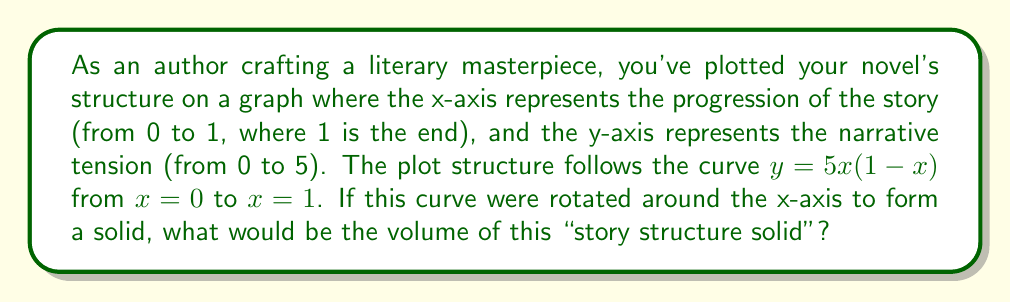Help me with this question. To solve this problem, we'll use the shell method for calculating the volume of a solid of revolution. The shell method is appropriate here because we're rotating around the x-axis, and our function is given in terms of y.

The formula for the volume using the shell method is:

$$V = 2\pi \int_a^b xf(x)dx$$

Where $f(x)$ is our function, and $a$ and $b$ are the limits of integration.

In our case:
$f(x) = 5x(1-x)$
$a = 0$
$b = 1$

Let's substitute these into our formula:

$$V = 2\pi \int_0^1 x[5x(1-x)]dx$$

Simplify the integrand:
$$V = 2\pi \int_0^1 (5x^2 - 5x^3)dx$$

Now, let's integrate:

$$V = 2\pi [\frac{5x^3}{3} - \frac{5x^4}{4}]_0^1$$

Evaluate the integral at the limits:

$$V = 2\pi [(\frac{5}{3} - \frac{5}{4}) - (0 - 0)]$$

$$V = 2\pi [\frac{20}{12} - \frac{15}{12}]$$

$$V = 2\pi [\frac{5}{12}]$$

$$V = \frac{5\pi}{6}$$

Therefore, the volume of the "story structure solid" is $\frac{5\pi}{6}$ cubic units.
Answer: $\frac{5\pi}{6}$ cubic units 